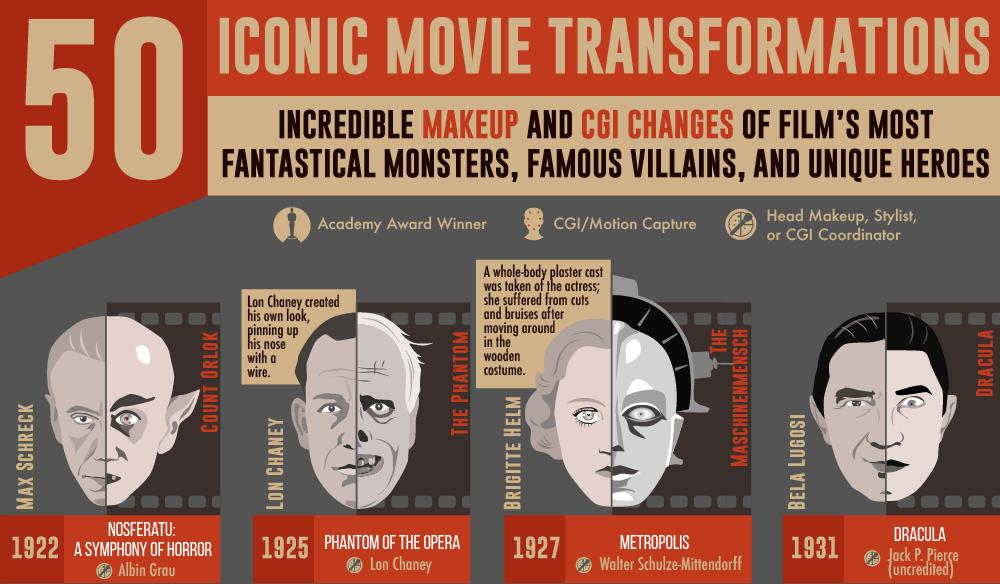Draw attention to some important aspects in this diagram. Bela Lugosi played the role of Dracula in the movie. The main actor in the movie was Brigitte Helm, and the movie was "The Maschinenmensch. Brighitte Helm suffered injuries as a result of her costume," declares the witness. Nosferatu was released in 1922. Walter Schulze-Mittendorf was the Head Makeup or Stylist for the film Metropolis. 